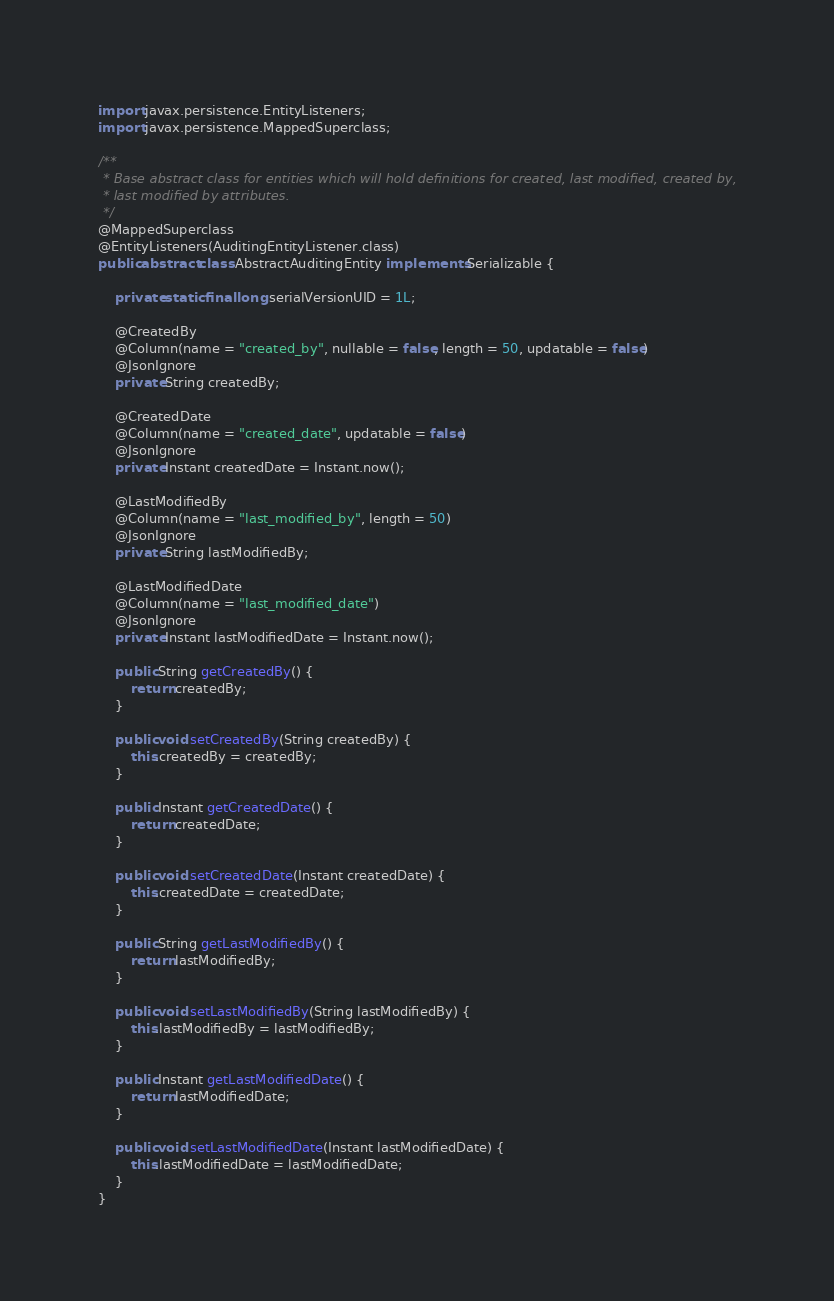<code> <loc_0><loc_0><loc_500><loc_500><_Java_>import javax.persistence.EntityListeners;
import javax.persistence.MappedSuperclass;

/**
 * Base abstract class for entities which will hold definitions for created, last modified, created by,
 * last modified by attributes.
 */
@MappedSuperclass
@EntityListeners(AuditingEntityListener.class)
public abstract class AbstractAuditingEntity implements Serializable {

    private static final long serialVersionUID = 1L;

    @CreatedBy
    @Column(name = "created_by", nullable = false, length = 50, updatable = false)
    @JsonIgnore
    private String createdBy;

    @CreatedDate
    @Column(name = "created_date", updatable = false)
    @JsonIgnore
    private Instant createdDate = Instant.now();

    @LastModifiedBy
    @Column(name = "last_modified_by", length = 50)
    @JsonIgnore
    private String lastModifiedBy;

    @LastModifiedDate
    @Column(name = "last_modified_date")
    @JsonIgnore
    private Instant lastModifiedDate = Instant.now();

    public String getCreatedBy() {
        return createdBy;
    }

    public void setCreatedBy(String createdBy) {
        this.createdBy = createdBy;
    }

    public Instant getCreatedDate() {
        return createdDate;
    }

    public void setCreatedDate(Instant createdDate) {
        this.createdDate = createdDate;
    }

    public String getLastModifiedBy() {
        return lastModifiedBy;
    }

    public void setLastModifiedBy(String lastModifiedBy) {
        this.lastModifiedBy = lastModifiedBy;
    }

    public Instant getLastModifiedDate() {
        return lastModifiedDate;
    }

    public void setLastModifiedDate(Instant lastModifiedDate) {
        this.lastModifiedDate = lastModifiedDate;
    }
}
</code> 